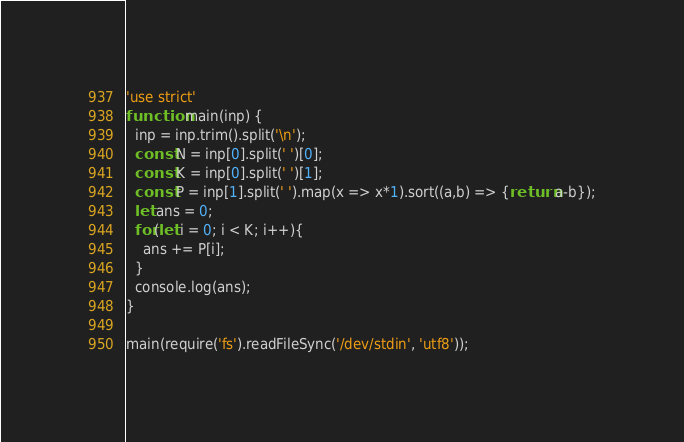Convert code to text. <code><loc_0><loc_0><loc_500><loc_500><_TypeScript_>'use strict'
function main(inp) {
  inp = inp.trim().split('\n');
  const N = inp[0].split(' ')[0];
  const K = inp[0].split(' ')[1];
  const P = inp[1].split(' ').map(x => x*1).sort((a,b) => {return a-b});
  let ans = 0;
  for(let i = 0; i < K; i++){
  	ans += P[i];
  }
  console.log(ans);
}

main(require('fs').readFileSync('/dev/stdin', 'utf8'));
</code> 